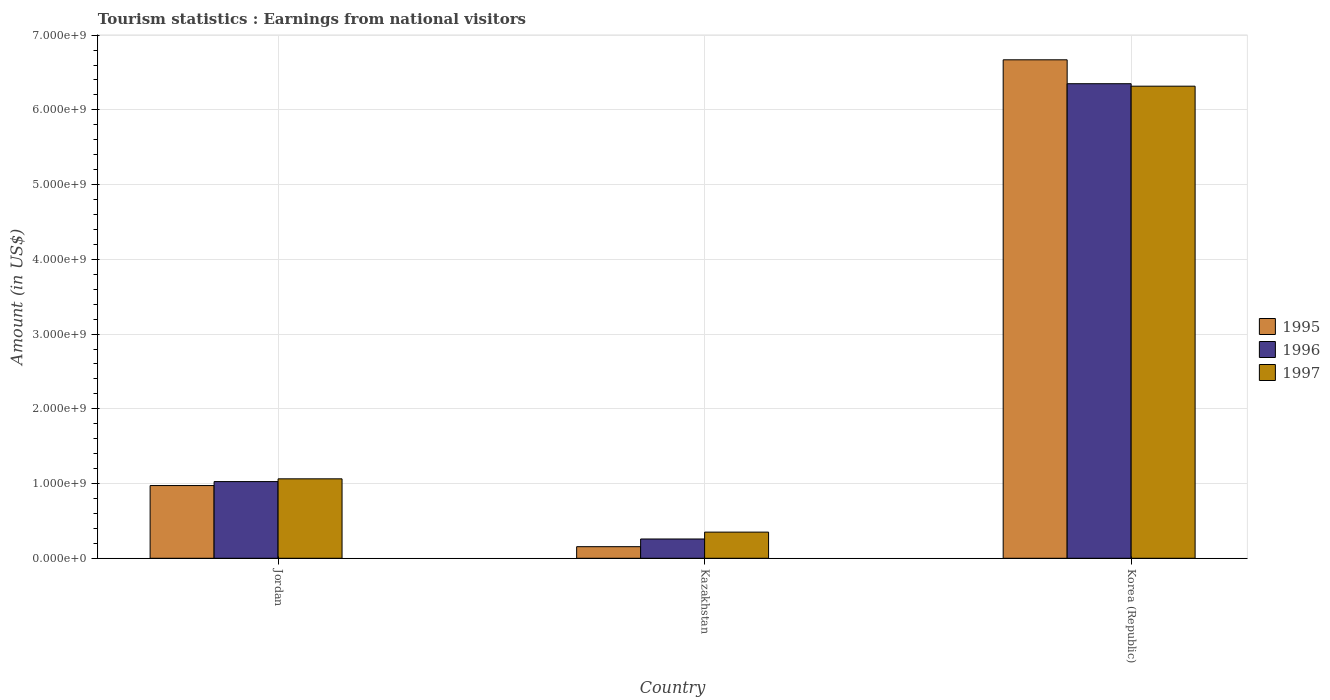How many different coloured bars are there?
Keep it short and to the point. 3. How many groups of bars are there?
Your answer should be very brief. 3. What is the label of the 1st group of bars from the left?
Ensure brevity in your answer.  Jordan. What is the earnings from national visitors in 1995 in Jordan?
Your answer should be compact. 9.73e+08. Across all countries, what is the maximum earnings from national visitors in 1996?
Ensure brevity in your answer.  6.35e+09. Across all countries, what is the minimum earnings from national visitors in 1995?
Give a very brief answer. 1.55e+08. In which country was the earnings from national visitors in 1995 maximum?
Offer a terse response. Korea (Republic). In which country was the earnings from national visitors in 1996 minimum?
Offer a very short reply. Kazakhstan. What is the total earnings from national visitors in 1996 in the graph?
Provide a short and direct response. 7.63e+09. What is the difference between the earnings from national visitors in 1996 in Jordan and that in Korea (Republic)?
Provide a short and direct response. -5.32e+09. What is the difference between the earnings from national visitors in 1996 in Jordan and the earnings from national visitors in 1997 in Korea (Republic)?
Ensure brevity in your answer.  -5.29e+09. What is the average earnings from national visitors in 1997 per country?
Ensure brevity in your answer.  2.58e+09. What is the difference between the earnings from national visitors of/in 1997 and earnings from national visitors of/in 1996 in Jordan?
Your answer should be very brief. 3.70e+07. In how many countries, is the earnings from national visitors in 1995 greater than 400000000 US$?
Offer a very short reply. 2. What is the ratio of the earnings from national visitors in 1997 in Jordan to that in Korea (Republic)?
Keep it short and to the point. 0.17. Is the earnings from national visitors in 1996 in Jordan less than that in Korea (Republic)?
Your answer should be very brief. Yes. What is the difference between the highest and the second highest earnings from national visitors in 1996?
Provide a short and direct response. 6.09e+09. What is the difference between the highest and the lowest earnings from national visitors in 1995?
Make the answer very short. 6.52e+09. Is the sum of the earnings from national visitors in 1996 in Jordan and Kazakhstan greater than the maximum earnings from national visitors in 1995 across all countries?
Provide a succinct answer. No. What does the 1st bar from the left in Kazakhstan represents?
Offer a very short reply. 1995. What does the 1st bar from the right in Jordan represents?
Ensure brevity in your answer.  1997. How many bars are there?
Provide a short and direct response. 9. Are all the bars in the graph horizontal?
Make the answer very short. No. How many countries are there in the graph?
Make the answer very short. 3. What is the difference between two consecutive major ticks on the Y-axis?
Make the answer very short. 1.00e+09. Are the values on the major ticks of Y-axis written in scientific E-notation?
Offer a terse response. Yes. Does the graph contain grids?
Keep it short and to the point. Yes. What is the title of the graph?
Your answer should be compact. Tourism statistics : Earnings from national visitors. Does "1966" appear as one of the legend labels in the graph?
Your response must be concise. No. What is the label or title of the Y-axis?
Make the answer very short. Amount (in US$). What is the Amount (in US$) of 1995 in Jordan?
Keep it short and to the point. 9.73e+08. What is the Amount (in US$) in 1996 in Jordan?
Offer a very short reply. 1.03e+09. What is the Amount (in US$) in 1997 in Jordan?
Your answer should be compact. 1.06e+09. What is the Amount (in US$) of 1995 in Kazakhstan?
Your response must be concise. 1.55e+08. What is the Amount (in US$) of 1996 in Kazakhstan?
Your response must be concise. 2.58e+08. What is the Amount (in US$) of 1997 in Kazakhstan?
Keep it short and to the point. 3.50e+08. What is the Amount (in US$) of 1995 in Korea (Republic)?
Your answer should be very brief. 6.67e+09. What is the Amount (in US$) of 1996 in Korea (Republic)?
Provide a succinct answer. 6.35e+09. What is the Amount (in US$) in 1997 in Korea (Republic)?
Make the answer very short. 6.32e+09. Across all countries, what is the maximum Amount (in US$) of 1995?
Give a very brief answer. 6.67e+09. Across all countries, what is the maximum Amount (in US$) in 1996?
Offer a very short reply. 6.35e+09. Across all countries, what is the maximum Amount (in US$) of 1997?
Offer a terse response. 6.32e+09. Across all countries, what is the minimum Amount (in US$) in 1995?
Offer a terse response. 1.55e+08. Across all countries, what is the minimum Amount (in US$) in 1996?
Your answer should be compact. 2.58e+08. Across all countries, what is the minimum Amount (in US$) of 1997?
Ensure brevity in your answer.  3.50e+08. What is the total Amount (in US$) of 1995 in the graph?
Provide a succinct answer. 7.80e+09. What is the total Amount (in US$) in 1996 in the graph?
Give a very brief answer. 7.63e+09. What is the total Amount (in US$) in 1997 in the graph?
Ensure brevity in your answer.  7.73e+09. What is the difference between the Amount (in US$) in 1995 in Jordan and that in Kazakhstan?
Ensure brevity in your answer.  8.18e+08. What is the difference between the Amount (in US$) of 1996 in Jordan and that in Kazakhstan?
Provide a succinct answer. 7.68e+08. What is the difference between the Amount (in US$) of 1997 in Jordan and that in Kazakhstan?
Your response must be concise. 7.13e+08. What is the difference between the Amount (in US$) of 1995 in Jordan and that in Korea (Republic)?
Make the answer very short. -5.70e+09. What is the difference between the Amount (in US$) in 1996 in Jordan and that in Korea (Republic)?
Give a very brief answer. -5.32e+09. What is the difference between the Amount (in US$) in 1997 in Jordan and that in Korea (Republic)?
Your answer should be compact. -5.25e+09. What is the difference between the Amount (in US$) of 1995 in Kazakhstan and that in Korea (Republic)?
Your answer should be compact. -6.52e+09. What is the difference between the Amount (in US$) of 1996 in Kazakhstan and that in Korea (Republic)?
Provide a succinct answer. -6.09e+09. What is the difference between the Amount (in US$) in 1997 in Kazakhstan and that in Korea (Republic)?
Your answer should be compact. -5.97e+09. What is the difference between the Amount (in US$) in 1995 in Jordan and the Amount (in US$) in 1996 in Kazakhstan?
Provide a short and direct response. 7.15e+08. What is the difference between the Amount (in US$) in 1995 in Jordan and the Amount (in US$) in 1997 in Kazakhstan?
Offer a terse response. 6.23e+08. What is the difference between the Amount (in US$) of 1996 in Jordan and the Amount (in US$) of 1997 in Kazakhstan?
Give a very brief answer. 6.76e+08. What is the difference between the Amount (in US$) of 1995 in Jordan and the Amount (in US$) of 1996 in Korea (Republic)?
Keep it short and to the point. -5.38e+09. What is the difference between the Amount (in US$) in 1995 in Jordan and the Amount (in US$) in 1997 in Korea (Republic)?
Give a very brief answer. -5.34e+09. What is the difference between the Amount (in US$) in 1996 in Jordan and the Amount (in US$) in 1997 in Korea (Republic)?
Your answer should be compact. -5.29e+09. What is the difference between the Amount (in US$) in 1995 in Kazakhstan and the Amount (in US$) in 1996 in Korea (Republic)?
Provide a succinct answer. -6.20e+09. What is the difference between the Amount (in US$) of 1995 in Kazakhstan and the Amount (in US$) of 1997 in Korea (Republic)?
Your response must be concise. -6.16e+09. What is the difference between the Amount (in US$) of 1996 in Kazakhstan and the Amount (in US$) of 1997 in Korea (Republic)?
Give a very brief answer. -6.06e+09. What is the average Amount (in US$) of 1995 per country?
Ensure brevity in your answer.  2.60e+09. What is the average Amount (in US$) in 1996 per country?
Ensure brevity in your answer.  2.54e+09. What is the average Amount (in US$) in 1997 per country?
Give a very brief answer. 2.58e+09. What is the difference between the Amount (in US$) of 1995 and Amount (in US$) of 1996 in Jordan?
Make the answer very short. -5.30e+07. What is the difference between the Amount (in US$) in 1995 and Amount (in US$) in 1997 in Jordan?
Offer a very short reply. -9.00e+07. What is the difference between the Amount (in US$) of 1996 and Amount (in US$) of 1997 in Jordan?
Provide a succinct answer. -3.70e+07. What is the difference between the Amount (in US$) in 1995 and Amount (in US$) in 1996 in Kazakhstan?
Offer a very short reply. -1.03e+08. What is the difference between the Amount (in US$) of 1995 and Amount (in US$) of 1997 in Kazakhstan?
Give a very brief answer. -1.95e+08. What is the difference between the Amount (in US$) of 1996 and Amount (in US$) of 1997 in Kazakhstan?
Keep it short and to the point. -9.20e+07. What is the difference between the Amount (in US$) of 1995 and Amount (in US$) of 1996 in Korea (Republic)?
Keep it short and to the point. 3.20e+08. What is the difference between the Amount (in US$) in 1995 and Amount (in US$) in 1997 in Korea (Republic)?
Your response must be concise. 3.53e+08. What is the difference between the Amount (in US$) in 1996 and Amount (in US$) in 1997 in Korea (Republic)?
Your answer should be compact. 3.30e+07. What is the ratio of the Amount (in US$) in 1995 in Jordan to that in Kazakhstan?
Provide a succinct answer. 6.28. What is the ratio of the Amount (in US$) of 1996 in Jordan to that in Kazakhstan?
Make the answer very short. 3.98. What is the ratio of the Amount (in US$) in 1997 in Jordan to that in Kazakhstan?
Keep it short and to the point. 3.04. What is the ratio of the Amount (in US$) of 1995 in Jordan to that in Korea (Republic)?
Your answer should be very brief. 0.15. What is the ratio of the Amount (in US$) in 1996 in Jordan to that in Korea (Republic)?
Give a very brief answer. 0.16. What is the ratio of the Amount (in US$) in 1997 in Jordan to that in Korea (Republic)?
Offer a very short reply. 0.17. What is the ratio of the Amount (in US$) in 1995 in Kazakhstan to that in Korea (Republic)?
Keep it short and to the point. 0.02. What is the ratio of the Amount (in US$) of 1996 in Kazakhstan to that in Korea (Republic)?
Provide a short and direct response. 0.04. What is the ratio of the Amount (in US$) of 1997 in Kazakhstan to that in Korea (Republic)?
Provide a short and direct response. 0.06. What is the difference between the highest and the second highest Amount (in US$) of 1995?
Keep it short and to the point. 5.70e+09. What is the difference between the highest and the second highest Amount (in US$) in 1996?
Ensure brevity in your answer.  5.32e+09. What is the difference between the highest and the second highest Amount (in US$) of 1997?
Offer a very short reply. 5.25e+09. What is the difference between the highest and the lowest Amount (in US$) of 1995?
Ensure brevity in your answer.  6.52e+09. What is the difference between the highest and the lowest Amount (in US$) in 1996?
Ensure brevity in your answer.  6.09e+09. What is the difference between the highest and the lowest Amount (in US$) of 1997?
Your answer should be very brief. 5.97e+09. 